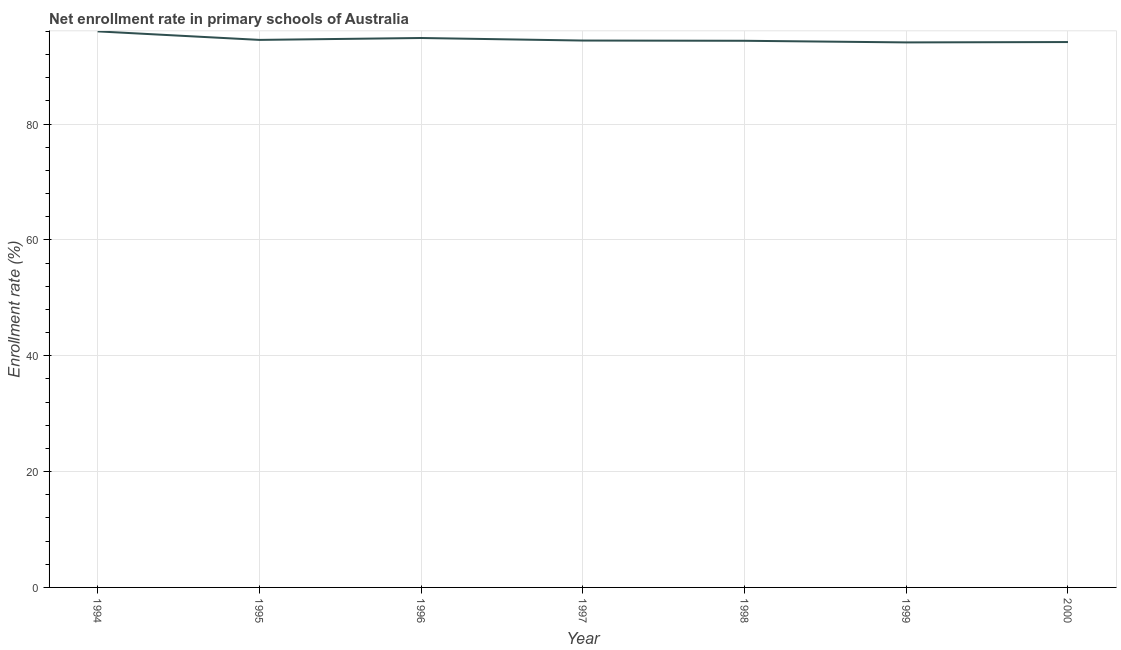What is the net enrollment rate in primary schools in 1999?
Give a very brief answer. 94.09. Across all years, what is the maximum net enrollment rate in primary schools?
Ensure brevity in your answer.  96. Across all years, what is the minimum net enrollment rate in primary schools?
Keep it short and to the point. 94.09. What is the sum of the net enrollment rate in primary schools?
Your answer should be very brief. 662.41. What is the difference between the net enrollment rate in primary schools in 1996 and 1998?
Provide a succinct answer. 0.48. What is the average net enrollment rate in primary schools per year?
Your response must be concise. 94.63. What is the median net enrollment rate in primary schools?
Ensure brevity in your answer.  94.41. In how many years, is the net enrollment rate in primary schools greater than 72 %?
Your response must be concise. 7. Do a majority of the years between 1998 and 1994 (inclusive) have net enrollment rate in primary schools greater than 8 %?
Make the answer very short. Yes. What is the ratio of the net enrollment rate in primary schools in 1998 to that in 2000?
Offer a very short reply. 1. Is the difference between the net enrollment rate in primary schools in 1997 and 1998 greater than the difference between any two years?
Ensure brevity in your answer.  No. What is the difference between the highest and the second highest net enrollment rate in primary schools?
Ensure brevity in your answer.  1.14. What is the difference between the highest and the lowest net enrollment rate in primary schools?
Your answer should be compact. 1.91. In how many years, is the net enrollment rate in primary schools greater than the average net enrollment rate in primary schools taken over all years?
Make the answer very short. 2. Does the net enrollment rate in primary schools monotonically increase over the years?
Offer a very short reply. No. How many lines are there?
Your answer should be compact. 1. What is the difference between two consecutive major ticks on the Y-axis?
Provide a succinct answer. 20. Does the graph contain any zero values?
Offer a very short reply. No. What is the title of the graph?
Your answer should be very brief. Net enrollment rate in primary schools of Australia. What is the label or title of the Y-axis?
Your answer should be compact. Enrollment rate (%). What is the Enrollment rate (%) of 1994?
Your response must be concise. 96. What is the Enrollment rate (%) of 1995?
Your answer should be compact. 94.53. What is the Enrollment rate (%) in 1996?
Make the answer very short. 94.85. What is the Enrollment rate (%) in 1997?
Offer a terse response. 94.41. What is the Enrollment rate (%) in 1998?
Your answer should be compact. 94.37. What is the Enrollment rate (%) in 1999?
Keep it short and to the point. 94.09. What is the Enrollment rate (%) in 2000?
Your answer should be compact. 94.15. What is the difference between the Enrollment rate (%) in 1994 and 1995?
Your answer should be compact. 1.47. What is the difference between the Enrollment rate (%) in 1994 and 1996?
Ensure brevity in your answer.  1.14. What is the difference between the Enrollment rate (%) in 1994 and 1997?
Keep it short and to the point. 1.58. What is the difference between the Enrollment rate (%) in 1994 and 1998?
Provide a short and direct response. 1.62. What is the difference between the Enrollment rate (%) in 1994 and 1999?
Give a very brief answer. 1.91. What is the difference between the Enrollment rate (%) in 1994 and 2000?
Make the answer very short. 1.84. What is the difference between the Enrollment rate (%) in 1995 and 1996?
Your answer should be compact. -0.33. What is the difference between the Enrollment rate (%) in 1995 and 1997?
Make the answer very short. 0.11. What is the difference between the Enrollment rate (%) in 1995 and 1998?
Keep it short and to the point. 0.15. What is the difference between the Enrollment rate (%) in 1995 and 1999?
Offer a terse response. 0.44. What is the difference between the Enrollment rate (%) in 1995 and 2000?
Your answer should be compact. 0.37. What is the difference between the Enrollment rate (%) in 1996 and 1997?
Your answer should be compact. 0.44. What is the difference between the Enrollment rate (%) in 1996 and 1998?
Your answer should be compact. 0.48. What is the difference between the Enrollment rate (%) in 1996 and 1999?
Make the answer very short. 0.76. What is the difference between the Enrollment rate (%) in 1996 and 2000?
Make the answer very short. 0.7. What is the difference between the Enrollment rate (%) in 1997 and 1998?
Ensure brevity in your answer.  0.04. What is the difference between the Enrollment rate (%) in 1997 and 1999?
Your response must be concise. 0.32. What is the difference between the Enrollment rate (%) in 1997 and 2000?
Provide a succinct answer. 0.26. What is the difference between the Enrollment rate (%) in 1998 and 1999?
Offer a terse response. 0.28. What is the difference between the Enrollment rate (%) in 1998 and 2000?
Your response must be concise. 0.22. What is the difference between the Enrollment rate (%) in 1999 and 2000?
Ensure brevity in your answer.  -0.06. What is the ratio of the Enrollment rate (%) in 1994 to that in 1997?
Ensure brevity in your answer.  1.02. What is the ratio of the Enrollment rate (%) in 1994 to that in 1999?
Keep it short and to the point. 1.02. What is the ratio of the Enrollment rate (%) in 1995 to that in 1998?
Ensure brevity in your answer.  1. What is the ratio of the Enrollment rate (%) in 1996 to that in 1998?
Make the answer very short. 1. What is the ratio of the Enrollment rate (%) in 1996 to that in 1999?
Keep it short and to the point. 1.01. What is the ratio of the Enrollment rate (%) in 1996 to that in 2000?
Offer a very short reply. 1.01. What is the ratio of the Enrollment rate (%) in 1997 to that in 1998?
Your answer should be compact. 1. What is the ratio of the Enrollment rate (%) in 1997 to that in 2000?
Keep it short and to the point. 1. What is the ratio of the Enrollment rate (%) in 1998 to that in 1999?
Offer a very short reply. 1. What is the ratio of the Enrollment rate (%) in 1998 to that in 2000?
Offer a terse response. 1. 